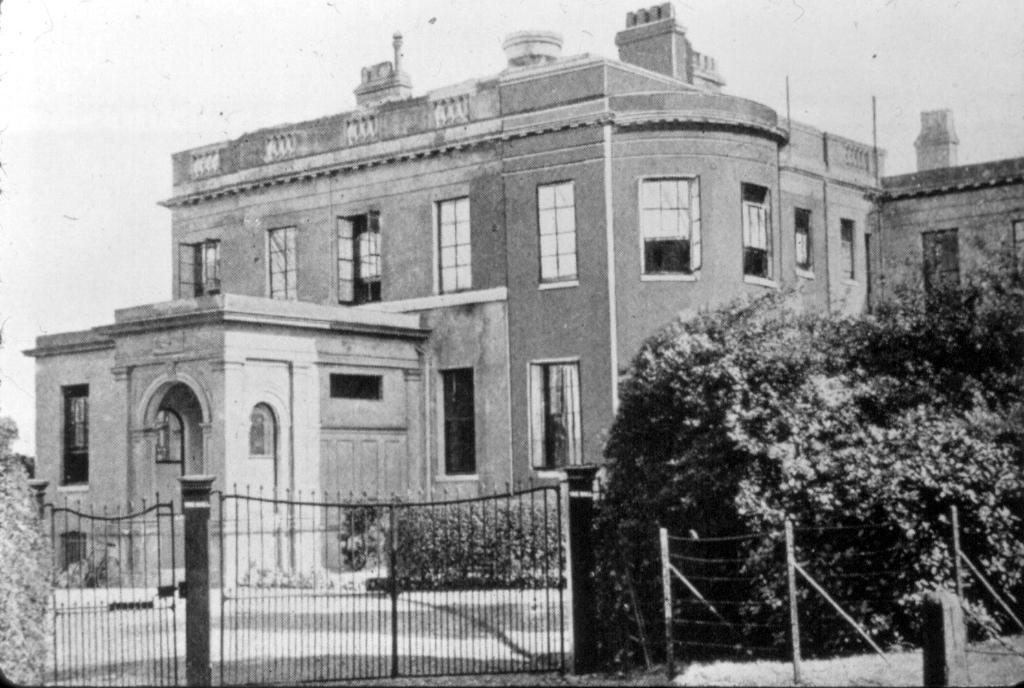In one or two sentences, can you explain what this image depicts? As we can see in the image there are buildings, windows, trees, gate and sky. 